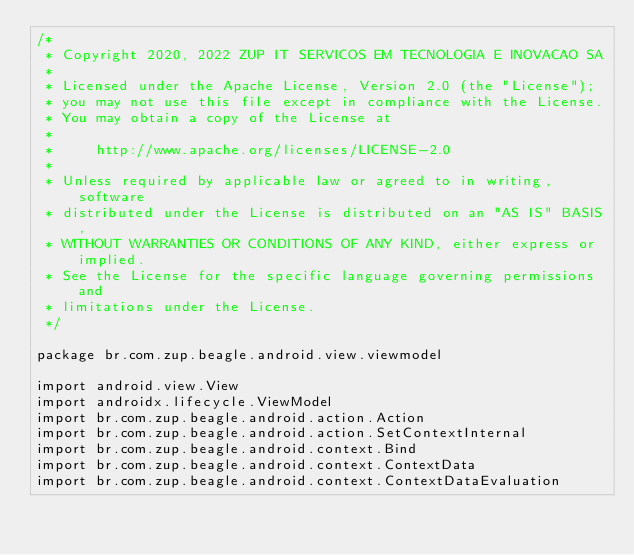<code> <loc_0><loc_0><loc_500><loc_500><_Kotlin_>/*
 * Copyright 2020, 2022 ZUP IT SERVICOS EM TECNOLOGIA E INOVACAO SA
 *
 * Licensed under the Apache License, Version 2.0 (the "License");
 * you may not use this file except in compliance with the License.
 * You may obtain a copy of the License at
 *
 *     http://www.apache.org/licenses/LICENSE-2.0
 *
 * Unless required by applicable law or agreed to in writing, software
 * distributed under the License is distributed on an "AS IS" BASIS,
 * WITHOUT WARRANTIES OR CONDITIONS OF ANY KIND, either express or implied.
 * See the License for the specific language governing permissions and
 * limitations under the License.
 */

package br.com.zup.beagle.android.view.viewmodel

import android.view.View
import androidx.lifecycle.ViewModel
import br.com.zup.beagle.android.action.Action
import br.com.zup.beagle.android.action.SetContextInternal
import br.com.zup.beagle.android.context.Bind
import br.com.zup.beagle.android.context.ContextData
import br.com.zup.beagle.android.context.ContextDataEvaluation</code> 